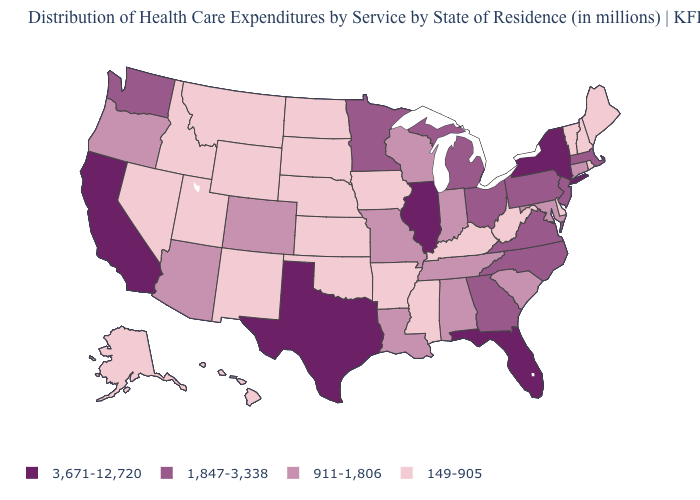Does Arkansas have a lower value than California?
Answer briefly. Yes. Which states have the lowest value in the USA?
Concise answer only. Alaska, Arkansas, Delaware, Hawaii, Idaho, Iowa, Kansas, Kentucky, Maine, Mississippi, Montana, Nebraska, Nevada, New Hampshire, New Mexico, North Dakota, Oklahoma, Rhode Island, South Dakota, Utah, Vermont, West Virginia, Wyoming. What is the value of Texas?
Write a very short answer. 3,671-12,720. How many symbols are there in the legend?
Quick response, please. 4. What is the value of California?
Give a very brief answer. 3,671-12,720. Does Kentucky have the highest value in the USA?
Be succinct. No. Name the states that have a value in the range 3,671-12,720?
Quick response, please. California, Florida, Illinois, New York, Texas. What is the value of Virginia?
Answer briefly. 1,847-3,338. What is the lowest value in the South?
Be succinct. 149-905. Among the states that border California , which have the lowest value?
Be succinct. Nevada. Among the states that border Louisiana , which have the lowest value?
Quick response, please. Arkansas, Mississippi. Does California have the same value as Florida?
Short answer required. Yes. Name the states that have a value in the range 149-905?
Write a very short answer. Alaska, Arkansas, Delaware, Hawaii, Idaho, Iowa, Kansas, Kentucky, Maine, Mississippi, Montana, Nebraska, Nevada, New Hampshire, New Mexico, North Dakota, Oklahoma, Rhode Island, South Dakota, Utah, Vermont, West Virginia, Wyoming. Among the states that border North Carolina , which have the lowest value?
Write a very short answer. South Carolina, Tennessee. Does Vermont have the same value as Florida?
Write a very short answer. No. 